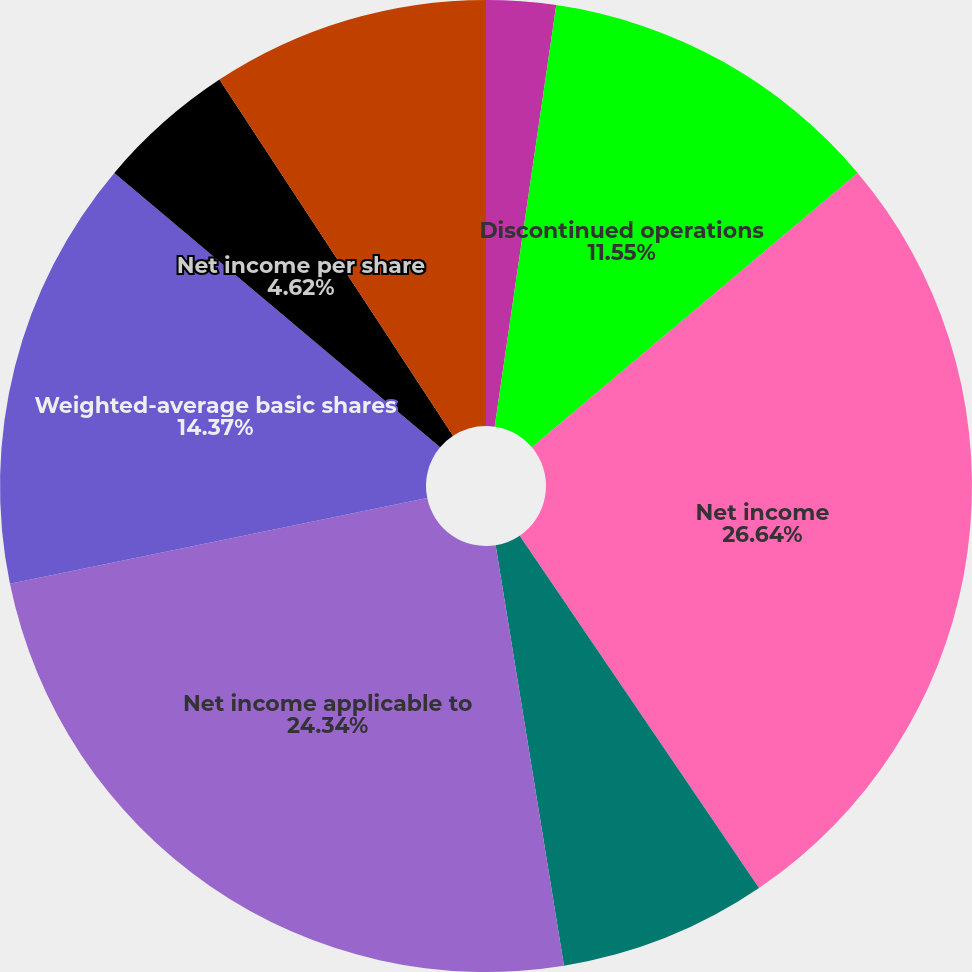Convert chart to OTSL. <chart><loc_0><loc_0><loc_500><loc_500><pie_chart><fcel>Income from continuing<fcel>Discontinued operations<fcel>Net income<fcel>Less preferred stock dividends<fcel>Net income applicable to<fcel>Weighted-average basic shares<fcel>Discontinued operations per<fcel>Net income per share<fcel>Add Employee restricted stock<nl><fcel>2.31%<fcel>11.55%<fcel>26.65%<fcel>6.93%<fcel>24.34%<fcel>14.37%<fcel>0.0%<fcel>4.62%<fcel>9.24%<nl></chart> 